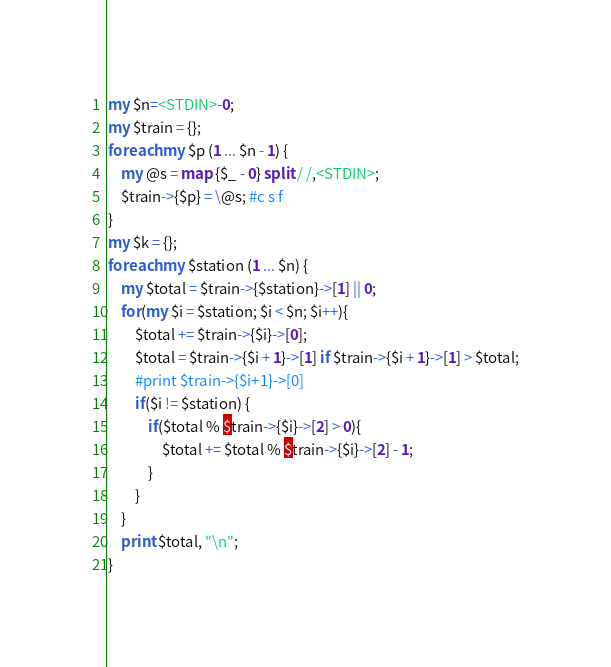Convert code to text. <code><loc_0><loc_0><loc_500><loc_500><_Perl_>my $n=<STDIN>-0;
my $train = {};
foreach my $p (1 ... $n - 1) {
    my @s = map {$_ - 0} split / /,<STDIN>;
    $train->{$p} = \@s; #c s f
}
my $k = {};
foreach my $station (1 ... $n) {
    my $total = $train->{$station}->[1] || 0;
    for(my $i = $station; $i < $n; $i++){
        $total += $train->{$i}->[0];
        $total = $train->{$i + 1}->[1] if $train->{$i + 1}->[1] > $total;
        #print $train->{$i+1}->[0]
        if($i != $station) {
            if($total % $train->{$i}->[2] > 0){
                $total += $total % $train->{$i}->[2] - 1;
            }
        }
    }
    print $total, "\n";
}</code> 